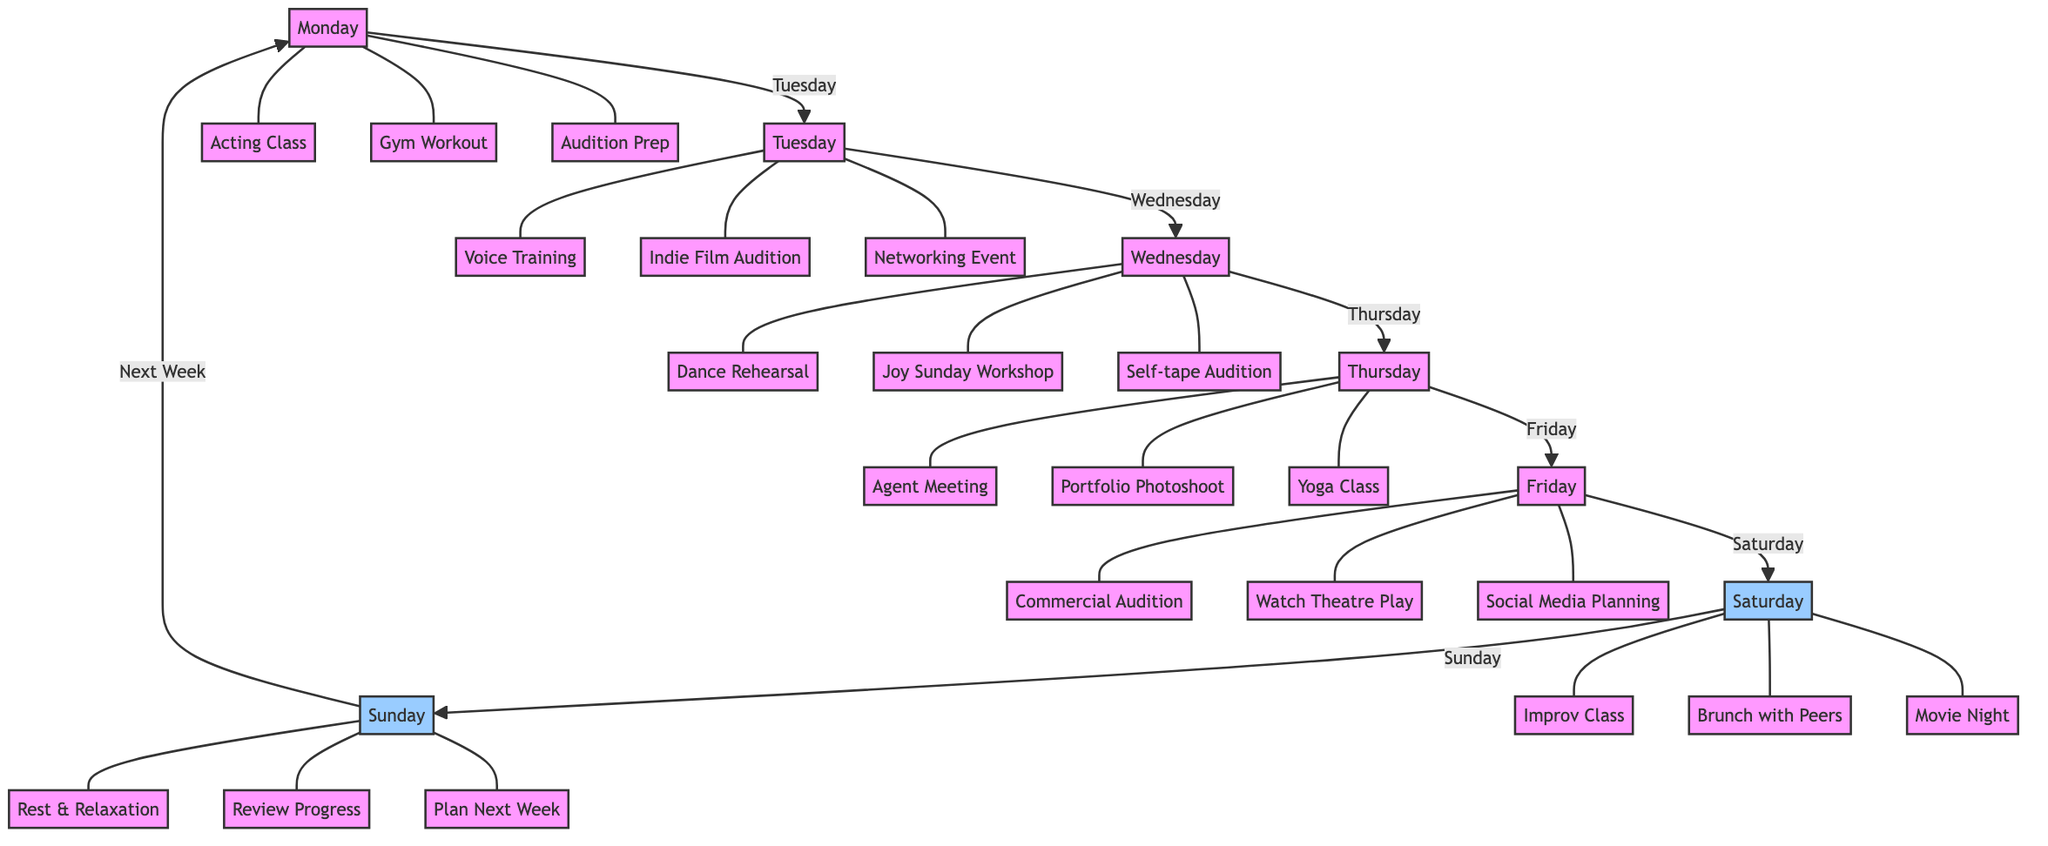What activities are scheduled for Wednesday? The diagram indicates that on Wednesday, three activities are scheduled: Dance Rehearsal, Joy Sunday Workshop, and Self-tape Audition. These activities are all linked to the Wednesday node, represented by the edges connecting them.
Answer: Dance Rehearsal, Joy Sunday Workshop, Self-tape Audition How many activities are scheduled for Saturday? On Saturday, the diagram lists three activities: Improv Class, Brunch with Peers, and Movie Night. Each of these activities is branching out from the Saturday node. Therefore, by counting these activities, we find the total is three.
Answer: 3 What is the link between Monday and Tuesday? The diagram shows a direct connection from Monday to Tuesday, represented by an arrow. This means that Tuesday is the following day after Monday, illustrating the flow of the week's schedule.
Answer: Tuesday Which day has an Agent Meeting scheduled? According to the diagram, the Agent Meeting is specifically listed under Thursday. This information can be deduced by locating the Thursday node and identifying the activities stemming from it.
Answer: Thursday What are the weekend activities listed in the diagram? The diagram indicates that the activities for the weekend (Saturday and Sunday) include Improv Class, Brunch with Peers, Movie Night on Saturday and Rest & Relaxation, Review Progress, Plan Next Week on Sunday. These are the activities directly linked to their corresponding weekend nodes.
Answer: Improv Class, Brunch with Peers, Movie Night, Rest & Relaxation, Review Progress, Plan Next Week How is Voice Training connected with Audition Prep? Voice Training is connected to Tuesday, while Audition Prep is connected to Monday. There is no direct link from Tuesday to Monday shown in the diagram; however, both days refer to activities essential for an aspiring actress's development. This indicates that while they are not directly connected, they both stem from the weekly schedule focused on progression.
Answer: Not directly connected What is the total number of nodes in the diagram? The diagram consists of seven day nodes (Monday to Sunday) and multiple activity nodes linked to each day. To find the total number of nodes, we count these and find that there are 10 activity nodes. Thus, in total, there are 17 nodes in the diagram.
Answer: 17 